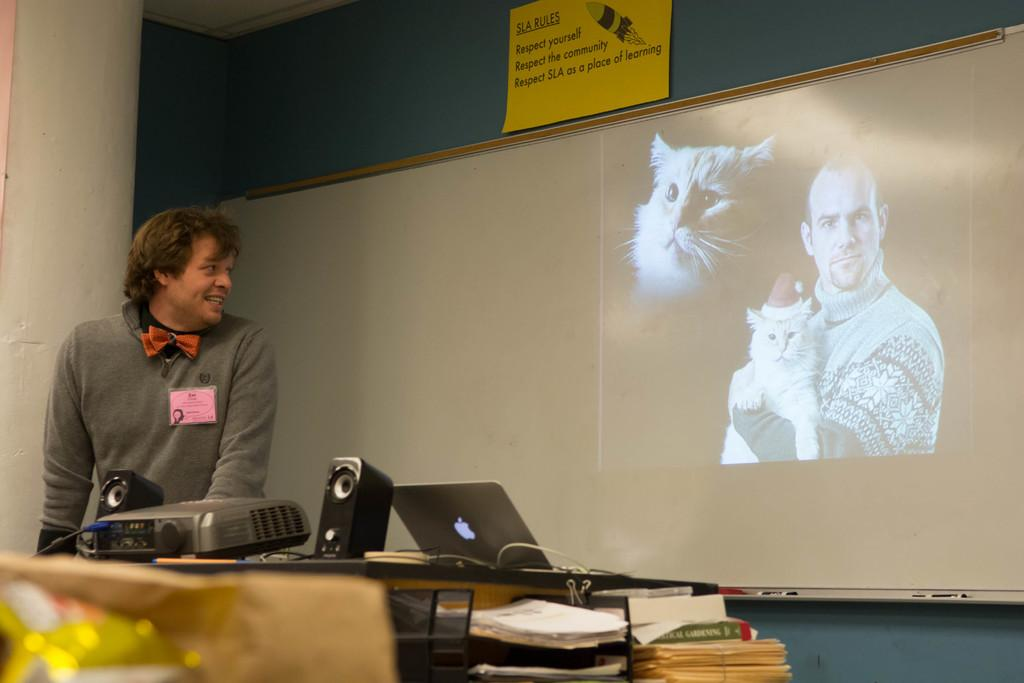Provide a one-sentence caption for the provided image. A man standing in front of an image of a man holding a cat in front of an SLA rules sign. 